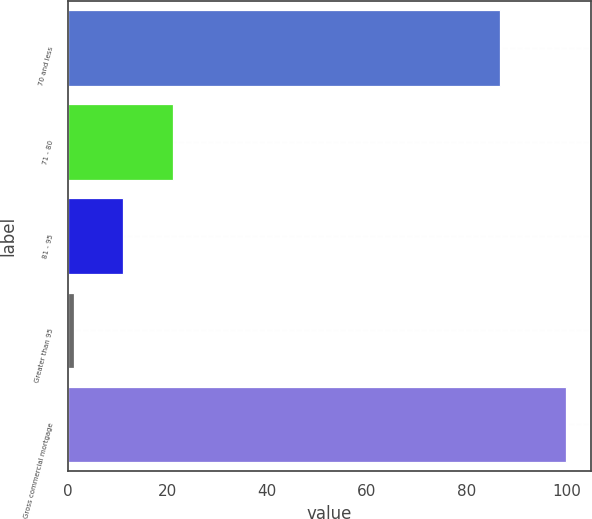Convert chart to OTSL. <chart><loc_0><loc_0><loc_500><loc_500><bar_chart><fcel>70 and less<fcel>71 - 80<fcel>81 - 95<fcel>Greater than 95<fcel>Gross commercial mortgage<nl><fcel>86.6<fcel>21.04<fcel>11.17<fcel>1.3<fcel>100<nl></chart> 